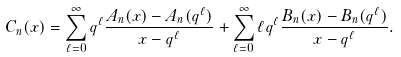Convert formula to latex. <formula><loc_0><loc_0><loc_500><loc_500>C _ { n } ( x ) = \sum _ { \ell = 0 } ^ { \infty } q ^ { \ell } \frac { A _ { n } ( x ) - A _ { n } ( q ^ { \ell } ) } { x - q ^ { \ell } } + \sum _ { \ell = 0 } ^ { \infty } \ell q ^ { \ell } \frac { B _ { n } ( x ) - B _ { n } ( q ^ { \ell } ) } { x - q ^ { \ell } } .</formula> 